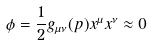Convert formula to latex. <formula><loc_0><loc_0><loc_500><loc_500>\phi = \frac { 1 } { 2 } g _ { \mu \nu } ( p ) x ^ { \mu } x ^ { \nu } \approx 0</formula> 